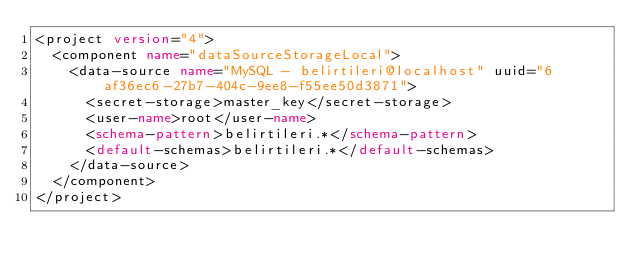Convert code to text. <code><loc_0><loc_0><loc_500><loc_500><_XML_><project version="4">
  <component name="dataSourceStorageLocal">
    <data-source name="MySQL - belirtileri@localhost" uuid="6af36ec6-27b7-404c-9ee8-f55ee50d3871">
      <secret-storage>master_key</secret-storage>
      <user-name>root</user-name>
      <schema-pattern>belirtileri.*</schema-pattern>
      <default-schemas>belirtileri.*</default-schemas>
    </data-source>
  </component>
</project></code> 